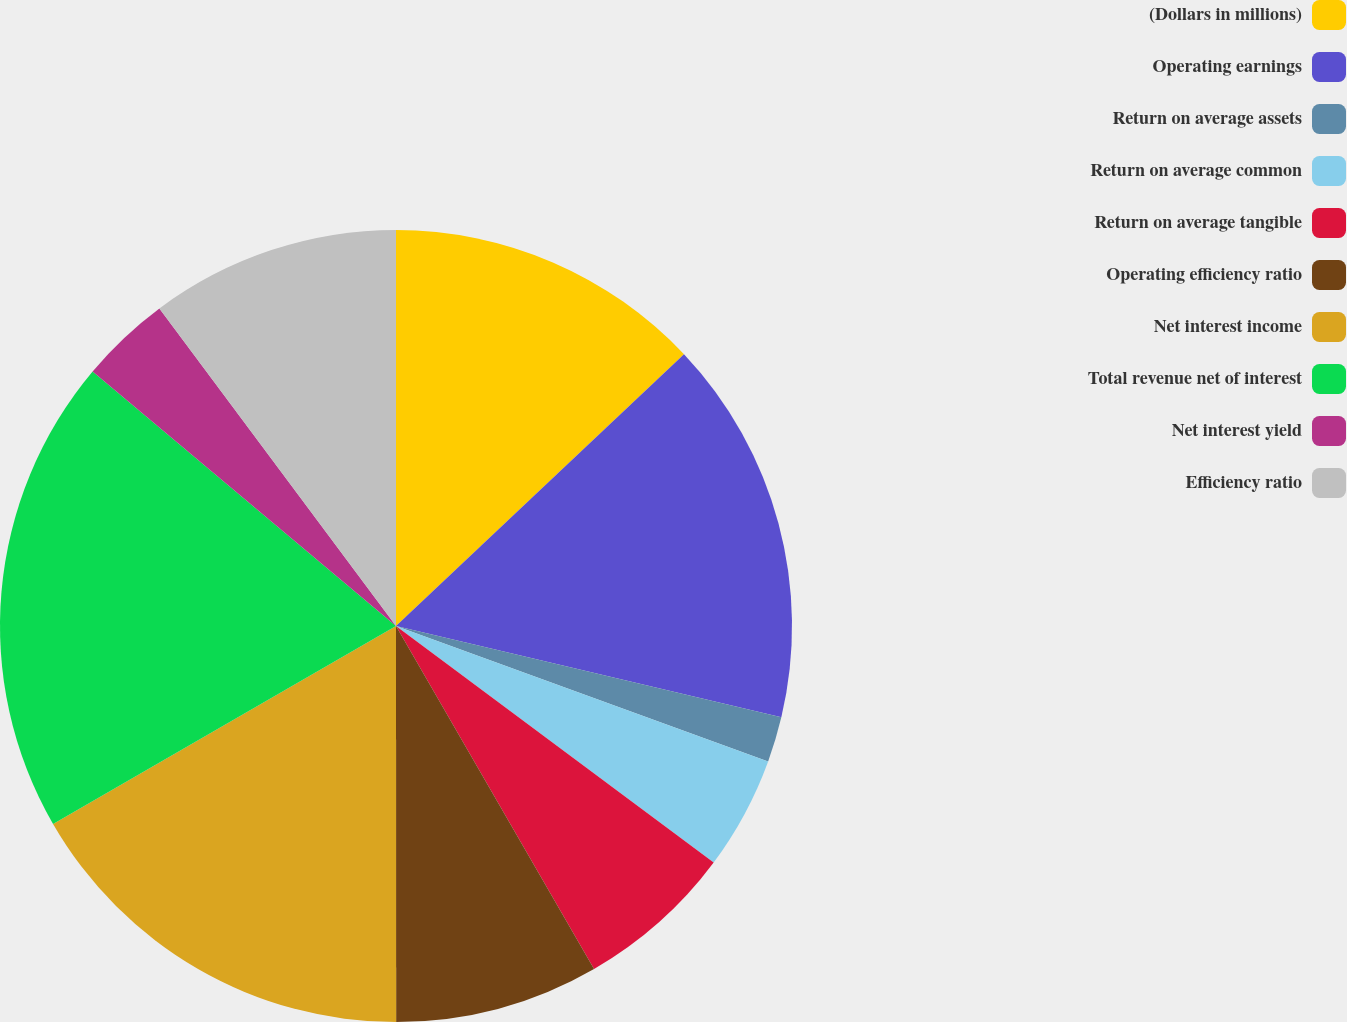<chart> <loc_0><loc_0><loc_500><loc_500><pie_chart><fcel>(Dollars in millions)<fcel>Operating earnings<fcel>Return on average assets<fcel>Return on average common<fcel>Return on average tangible<fcel>Operating efficiency ratio<fcel>Net interest income<fcel>Total revenue net of interest<fcel>Net interest yield<fcel>Efficiency ratio<nl><fcel>12.96%<fcel>15.74%<fcel>1.85%<fcel>4.63%<fcel>6.48%<fcel>8.33%<fcel>16.67%<fcel>19.44%<fcel>3.7%<fcel>10.19%<nl></chart> 